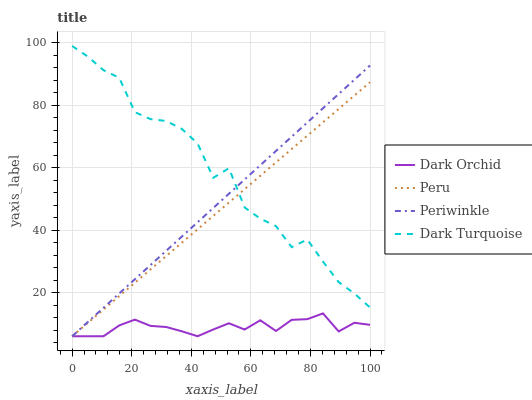Does Dark Orchid have the minimum area under the curve?
Answer yes or no. Yes. Does Dark Turquoise have the maximum area under the curve?
Answer yes or no. Yes. Does Periwinkle have the minimum area under the curve?
Answer yes or no. No. Does Periwinkle have the maximum area under the curve?
Answer yes or no. No. Is Peru the smoothest?
Answer yes or no. Yes. Is Dark Turquoise the roughest?
Answer yes or no. Yes. Is Periwinkle the smoothest?
Answer yes or no. No. Is Periwinkle the roughest?
Answer yes or no. No. Does Periwinkle have the lowest value?
Answer yes or no. Yes. Does Dark Turquoise have the highest value?
Answer yes or no. Yes. Does Periwinkle have the highest value?
Answer yes or no. No. Is Dark Orchid less than Dark Turquoise?
Answer yes or no. Yes. Is Dark Turquoise greater than Dark Orchid?
Answer yes or no. Yes. Does Peru intersect Periwinkle?
Answer yes or no. Yes. Is Peru less than Periwinkle?
Answer yes or no. No. Is Peru greater than Periwinkle?
Answer yes or no. No. Does Dark Orchid intersect Dark Turquoise?
Answer yes or no. No. 